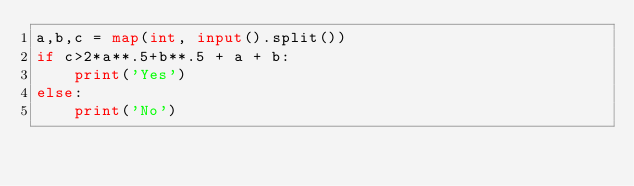<code> <loc_0><loc_0><loc_500><loc_500><_Python_>a,b,c = map(int, input().split())
if c>2*a**.5+b**.5 + a + b:
    print('Yes')
else:
    print('No')</code> 